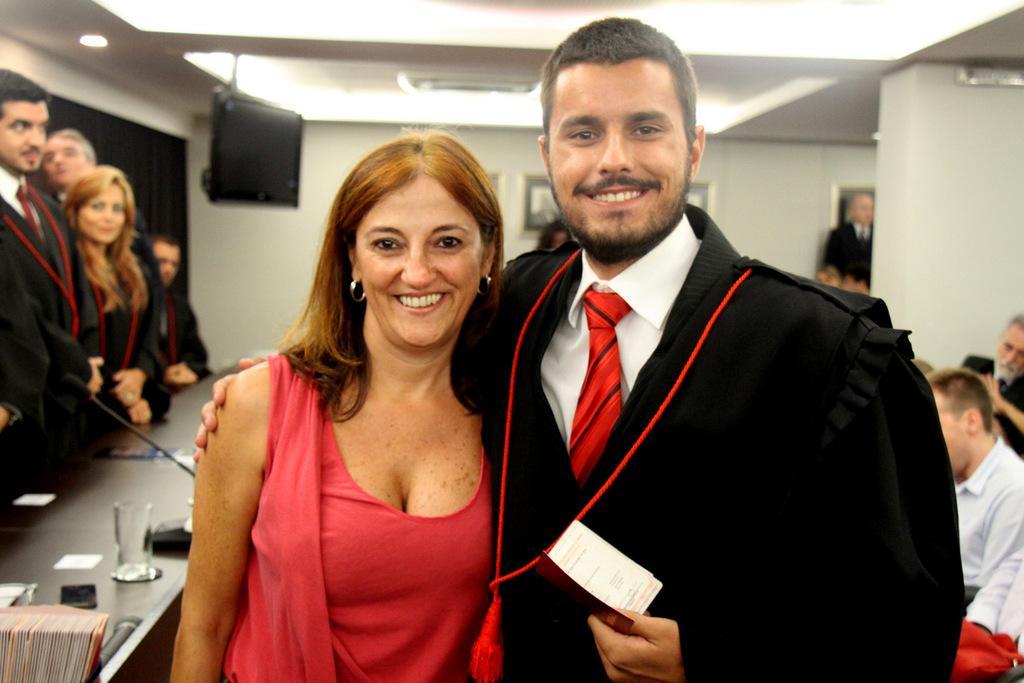Can you describe this image briefly? In this image there is a man and woman are giving pose for a photograph, on the right side there are people sitting on chairs, on the left side there are people standing, in front of them there is a table, on that table there is a glass, books and a mic, in the background there is a wall to that wall there is a monitor, at the top there is ceiling and lights. 